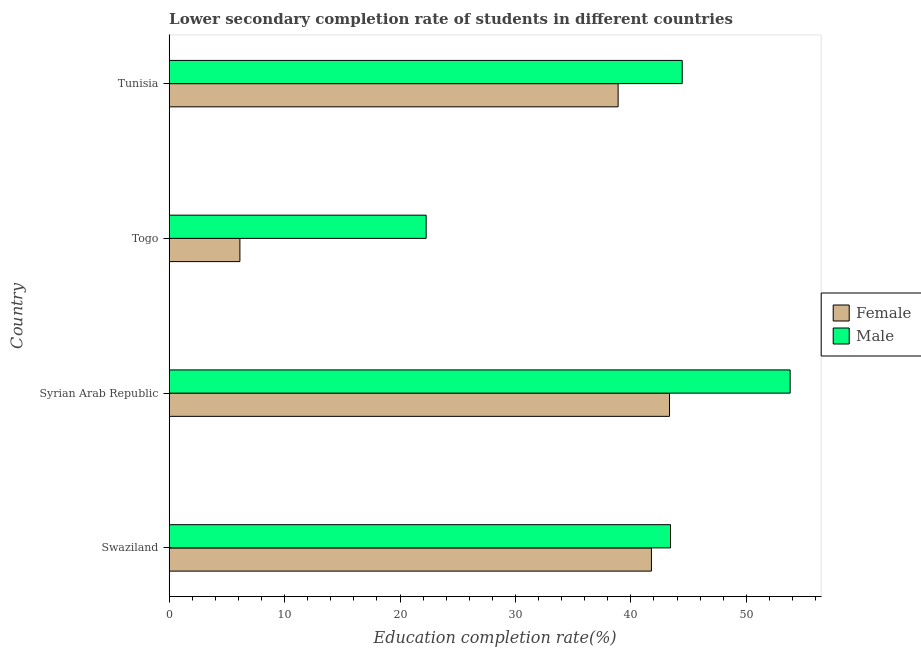How many different coloured bars are there?
Your response must be concise. 2. What is the label of the 2nd group of bars from the top?
Your response must be concise. Togo. In how many cases, is the number of bars for a given country not equal to the number of legend labels?
Make the answer very short. 0. What is the education completion rate of female students in Togo?
Keep it short and to the point. 6.13. Across all countries, what is the maximum education completion rate of male students?
Offer a terse response. 53.8. Across all countries, what is the minimum education completion rate of male students?
Offer a terse response. 22.26. In which country was the education completion rate of female students maximum?
Ensure brevity in your answer.  Syrian Arab Republic. In which country was the education completion rate of female students minimum?
Your answer should be very brief. Togo. What is the total education completion rate of female students in the graph?
Your answer should be compact. 130.15. What is the difference between the education completion rate of female students in Swaziland and that in Syrian Arab Republic?
Give a very brief answer. -1.57. What is the difference between the education completion rate of female students in Togo and the education completion rate of male students in Tunisia?
Provide a short and direct response. -38.32. What is the average education completion rate of male students per country?
Keep it short and to the point. 40.99. What is the difference between the education completion rate of male students and education completion rate of female students in Swaziland?
Your answer should be compact. 1.66. In how many countries, is the education completion rate of male students greater than 38 %?
Provide a succinct answer. 3. What is the ratio of the education completion rate of female students in Swaziland to that in Togo?
Provide a succinct answer. 6.82. Is the difference between the education completion rate of male students in Swaziland and Syrian Arab Republic greater than the difference between the education completion rate of female students in Swaziland and Syrian Arab Republic?
Your answer should be very brief. No. What is the difference between the highest and the second highest education completion rate of male students?
Offer a terse response. 9.35. What is the difference between the highest and the lowest education completion rate of male students?
Provide a succinct answer. 31.54. In how many countries, is the education completion rate of female students greater than the average education completion rate of female students taken over all countries?
Your response must be concise. 3. Is the sum of the education completion rate of female students in Swaziland and Togo greater than the maximum education completion rate of male students across all countries?
Keep it short and to the point. No. What does the 1st bar from the top in Togo represents?
Provide a short and direct response. Male. What does the 2nd bar from the bottom in Togo represents?
Offer a terse response. Male. How many bars are there?
Make the answer very short. 8. Are all the bars in the graph horizontal?
Provide a succinct answer. Yes. What is the difference between two consecutive major ticks on the X-axis?
Your answer should be very brief. 10. Are the values on the major ticks of X-axis written in scientific E-notation?
Your answer should be compact. No. How are the legend labels stacked?
Make the answer very short. Vertical. What is the title of the graph?
Make the answer very short. Lower secondary completion rate of students in different countries. What is the label or title of the X-axis?
Your answer should be very brief. Education completion rate(%). What is the Education completion rate(%) in Female in Swaziland?
Give a very brief answer. 41.78. What is the Education completion rate(%) of Male in Swaziland?
Make the answer very short. 43.43. What is the Education completion rate(%) in Female in Syrian Arab Republic?
Your answer should be very brief. 43.35. What is the Education completion rate(%) of Male in Syrian Arab Republic?
Provide a succinct answer. 53.8. What is the Education completion rate(%) in Female in Togo?
Ensure brevity in your answer.  6.13. What is the Education completion rate(%) in Male in Togo?
Give a very brief answer. 22.26. What is the Education completion rate(%) in Female in Tunisia?
Keep it short and to the point. 38.89. What is the Education completion rate(%) in Male in Tunisia?
Give a very brief answer. 44.45. Across all countries, what is the maximum Education completion rate(%) of Female?
Offer a terse response. 43.35. Across all countries, what is the maximum Education completion rate(%) of Male?
Ensure brevity in your answer.  53.8. Across all countries, what is the minimum Education completion rate(%) in Female?
Your response must be concise. 6.13. Across all countries, what is the minimum Education completion rate(%) in Male?
Provide a short and direct response. 22.26. What is the total Education completion rate(%) in Female in the graph?
Keep it short and to the point. 130.15. What is the total Education completion rate(%) in Male in the graph?
Your answer should be very brief. 163.94. What is the difference between the Education completion rate(%) of Female in Swaziland and that in Syrian Arab Republic?
Keep it short and to the point. -1.57. What is the difference between the Education completion rate(%) of Male in Swaziland and that in Syrian Arab Republic?
Offer a terse response. -10.36. What is the difference between the Education completion rate(%) in Female in Swaziland and that in Togo?
Ensure brevity in your answer.  35.65. What is the difference between the Education completion rate(%) in Male in Swaziland and that in Togo?
Provide a succinct answer. 21.17. What is the difference between the Education completion rate(%) in Female in Swaziland and that in Tunisia?
Offer a very short reply. 2.89. What is the difference between the Education completion rate(%) of Male in Swaziland and that in Tunisia?
Keep it short and to the point. -1.01. What is the difference between the Education completion rate(%) in Female in Syrian Arab Republic and that in Togo?
Your answer should be compact. 37.22. What is the difference between the Education completion rate(%) of Male in Syrian Arab Republic and that in Togo?
Offer a very short reply. 31.54. What is the difference between the Education completion rate(%) of Female in Syrian Arab Republic and that in Tunisia?
Provide a short and direct response. 4.45. What is the difference between the Education completion rate(%) of Male in Syrian Arab Republic and that in Tunisia?
Your answer should be very brief. 9.35. What is the difference between the Education completion rate(%) in Female in Togo and that in Tunisia?
Your response must be concise. -32.77. What is the difference between the Education completion rate(%) in Male in Togo and that in Tunisia?
Provide a short and direct response. -22.19. What is the difference between the Education completion rate(%) in Female in Swaziland and the Education completion rate(%) in Male in Syrian Arab Republic?
Ensure brevity in your answer.  -12.02. What is the difference between the Education completion rate(%) of Female in Swaziland and the Education completion rate(%) of Male in Togo?
Make the answer very short. 19.52. What is the difference between the Education completion rate(%) of Female in Swaziland and the Education completion rate(%) of Male in Tunisia?
Give a very brief answer. -2.67. What is the difference between the Education completion rate(%) of Female in Syrian Arab Republic and the Education completion rate(%) of Male in Togo?
Your answer should be very brief. 21.08. What is the difference between the Education completion rate(%) in Female in Syrian Arab Republic and the Education completion rate(%) in Male in Tunisia?
Provide a short and direct response. -1.1. What is the difference between the Education completion rate(%) in Female in Togo and the Education completion rate(%) in Male in Tunisia?
Provide a short and direct response. -38.32. What is the average Education completion rate(%) of Female per country?
Offer a terse response. 32.54. What is the average Education completion rate(%) of Male per country?
Offer a very short reply. 40.99. What is the difference between the Education completion rate(%) in Female and Education completion rate(%) in Male in Swaziland?
Make the answer very short. -1.66. What is the difference between the Education completion rate(%) of Female and Education completion rate(%) of Male in Syrian Arab Republic?
Offer a very short reply. -10.45. What is the difference between the Education completion rate(%) in Female and Education completion rate(%) in Male in Togo?
Your answer should be very brief. -16.14. What is the difference between the Education completion rate(%) of Female and Education completion rate(%) of Male in Tunisia?
Provide a short and direct response. -5.55. What is the ratio of the Education completion rate(%) in Female in Swaziland to that in Syrian Arab Republic?
Offer a very short reply. 0.96. What is the ratio of the Education completion rate(%) in Male in Swaziland to that in Syrian Arab Republic?
Provide a succinct answer. 0.81. What is the ratio of the Education completion rate(%) in Female in Swaziland to that in Togo?
Keep it short and to the point. 6.82. What is the ratio of the Education completion rate(%) in Male in Swaziland to that in Togo?
Ensure brevity in your answer.  1.95. What is the ratio of the Education completion rate(%) in Female in Swaziland to that in Tunisia?
Offer a terse response. 1.07. What is the ratio of the Education completion rate(%) in Male in Swaziland to that in Tunisia?
Offer a very short reply. 0.98. What is the ratio of the Education completion rate(%) in Female in Syrian Arab Republic to that in Togo?
Make the answer very short. 7.08. What is the ratio of the Education completion rate(%) of Male in Syrian Arab Republic to that in Togo?
Offer a terse response. 2.42. What is the ratio of the Education completion rate(%) of Female in Syrian Arab Republic to that in Tunisia?
Keep it short and to the point. 1.11. What is the ratio of the Education completion rate(%) of Male in Syrian Arab Republic to that in Tunisia?
Offer a very short reply. 1.21. What is the ratio of the Education completion rate(%) of Female in Togo to that in Tunisia?
Make the answer very short. 0.16. What is the ratio of the Education completion rate(%) in Male in Togo to that in Tunisia?
Your answer should be compact. 0.5. What is the difference between the highest and the second highest Education completion rate(%) in Female?
Give a very brief answer. 1.57. What is the difference between the highest and the second highest Education completion rate(%) in Male?
Make the answer very short. 9.35. What is the difference between the highest and the lowest Education completion rate(%) of Female?
Your answer should be very brief. 37.22. What is the difference between the highest and the lowest Education completion rate(%) of Male?
Make the answer very short. 31.54. 